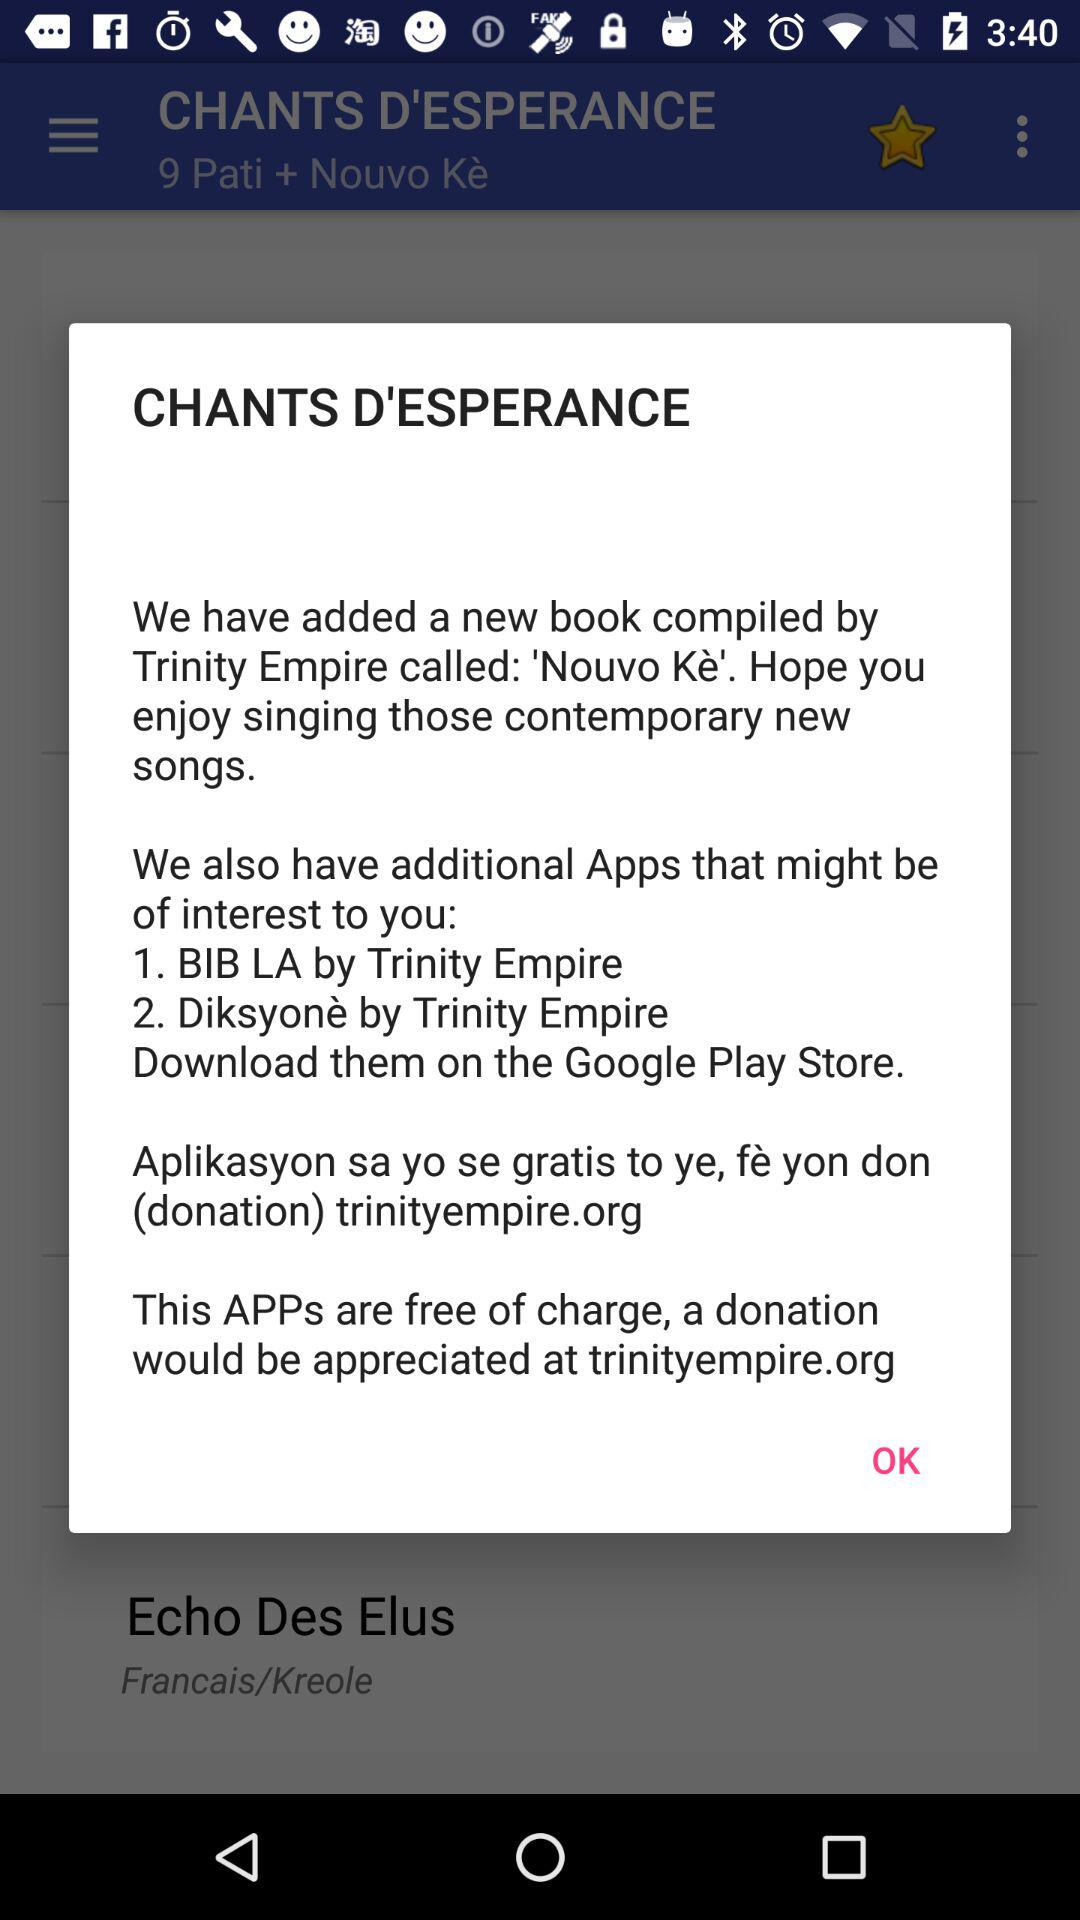From where can we download these apps? You can download these apps from the Google Play Store. 